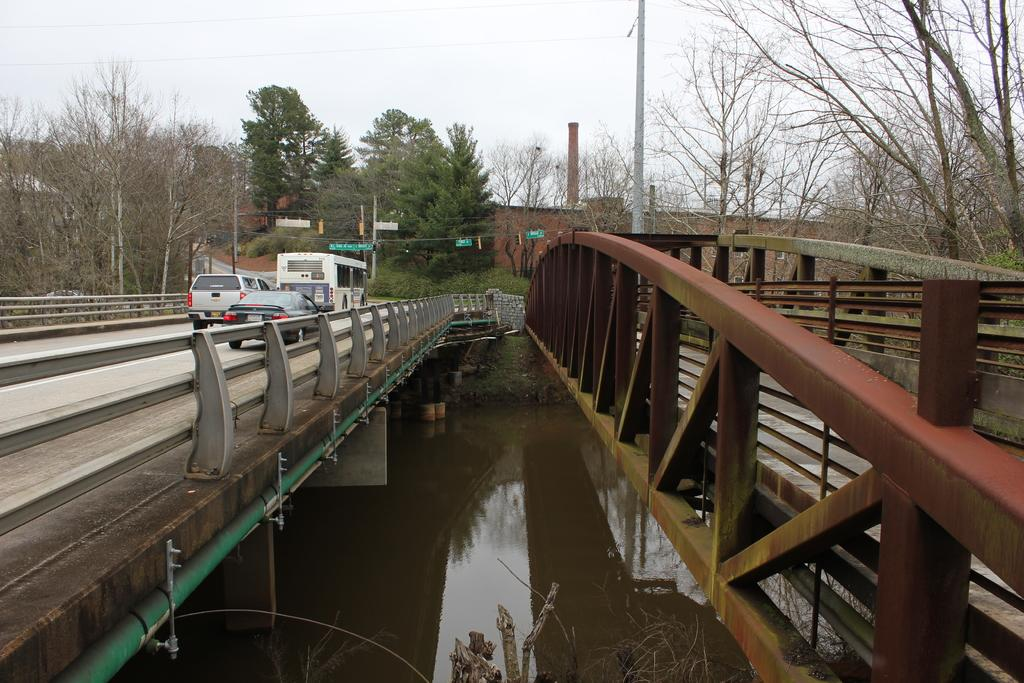What is the primary element visible in the image? There is water in the image. What structures can be seen crossing the water? There are bridges in the image. What types of transportation are present? Vehicles are present in the image. What safety features can be observed? Railings are visible in the image. What supports the infrastructure? Poles are present in the image. What materials are used for walking surfaces? Boards are visible in the image. What type of vegetation is present? Plants are present in the image. What type of barrier is in the image? There is a wall in the image. What type of tall vegetation is present? Trees are present in the image. What is visible in the distance? The sky is visible in the background of the image. What type of flower is blooming on the brake of the vehicle in the image? There is no flower or brake present on any vehicle in the image. 